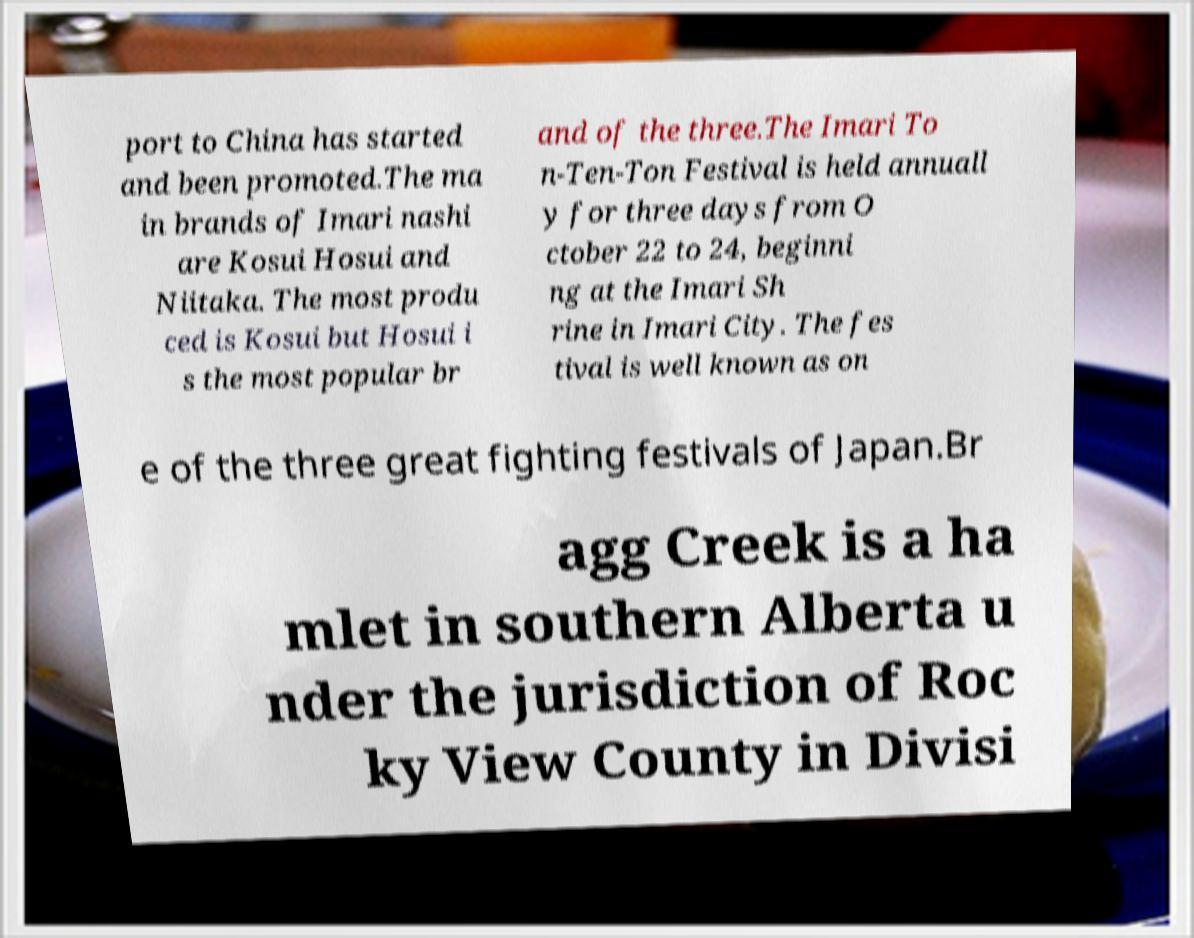I need the written content from this picture converted into text. Can you do that? port to China has started and been promoted.The ma in brands of Imari nashi are Kosui Hosui and Niitaka. The most produ ced is Kosui but Hosui i s the most popular br and of the three.The Imari To n-Ten-Ton Festival is held annuall y for three days from O ctober 22 to 24, beginni ng at the Imari Sh rine in Imari City. The fes tival is well known as on e of the three great fighting festivals of Japan.Br agg Creek is a ha mlet in southern Alberta u nder the jurisdiction of Roc ky View County in Divisi 